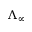<formula> <loc_0><loc_0><loc_500><loc_500>\Lambda _ { \infty }</formula> 